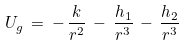<formula> <loc_0><loc_0><loc_500><loc_500>U _ { g } \, = \, - \, \frac { k } { r ^ { 2 } } \, - \, \frac { h _ { 1 } } { r ^ { 3 } } \, - \, \frac { h _ { 2 } } { r ^ { 3 } }</formula> 